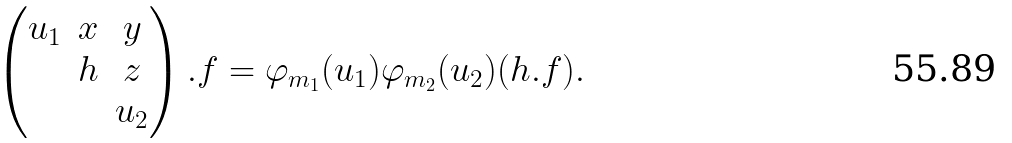Convert formula to latex. <formula><loc_0><loc_0><loc_500><loc_500>\begin{pmatrix} u _ { 1 } & x & y \\ & h & z \\ & & u _ { 2 } \end{pmatrix} . f = \varphi _ { m _ { 1 } } ( u _ { 1 } ) \varphi _ { m _ { 2 } } ( u _ { 2 } ) ( h . f ) .</formula> 